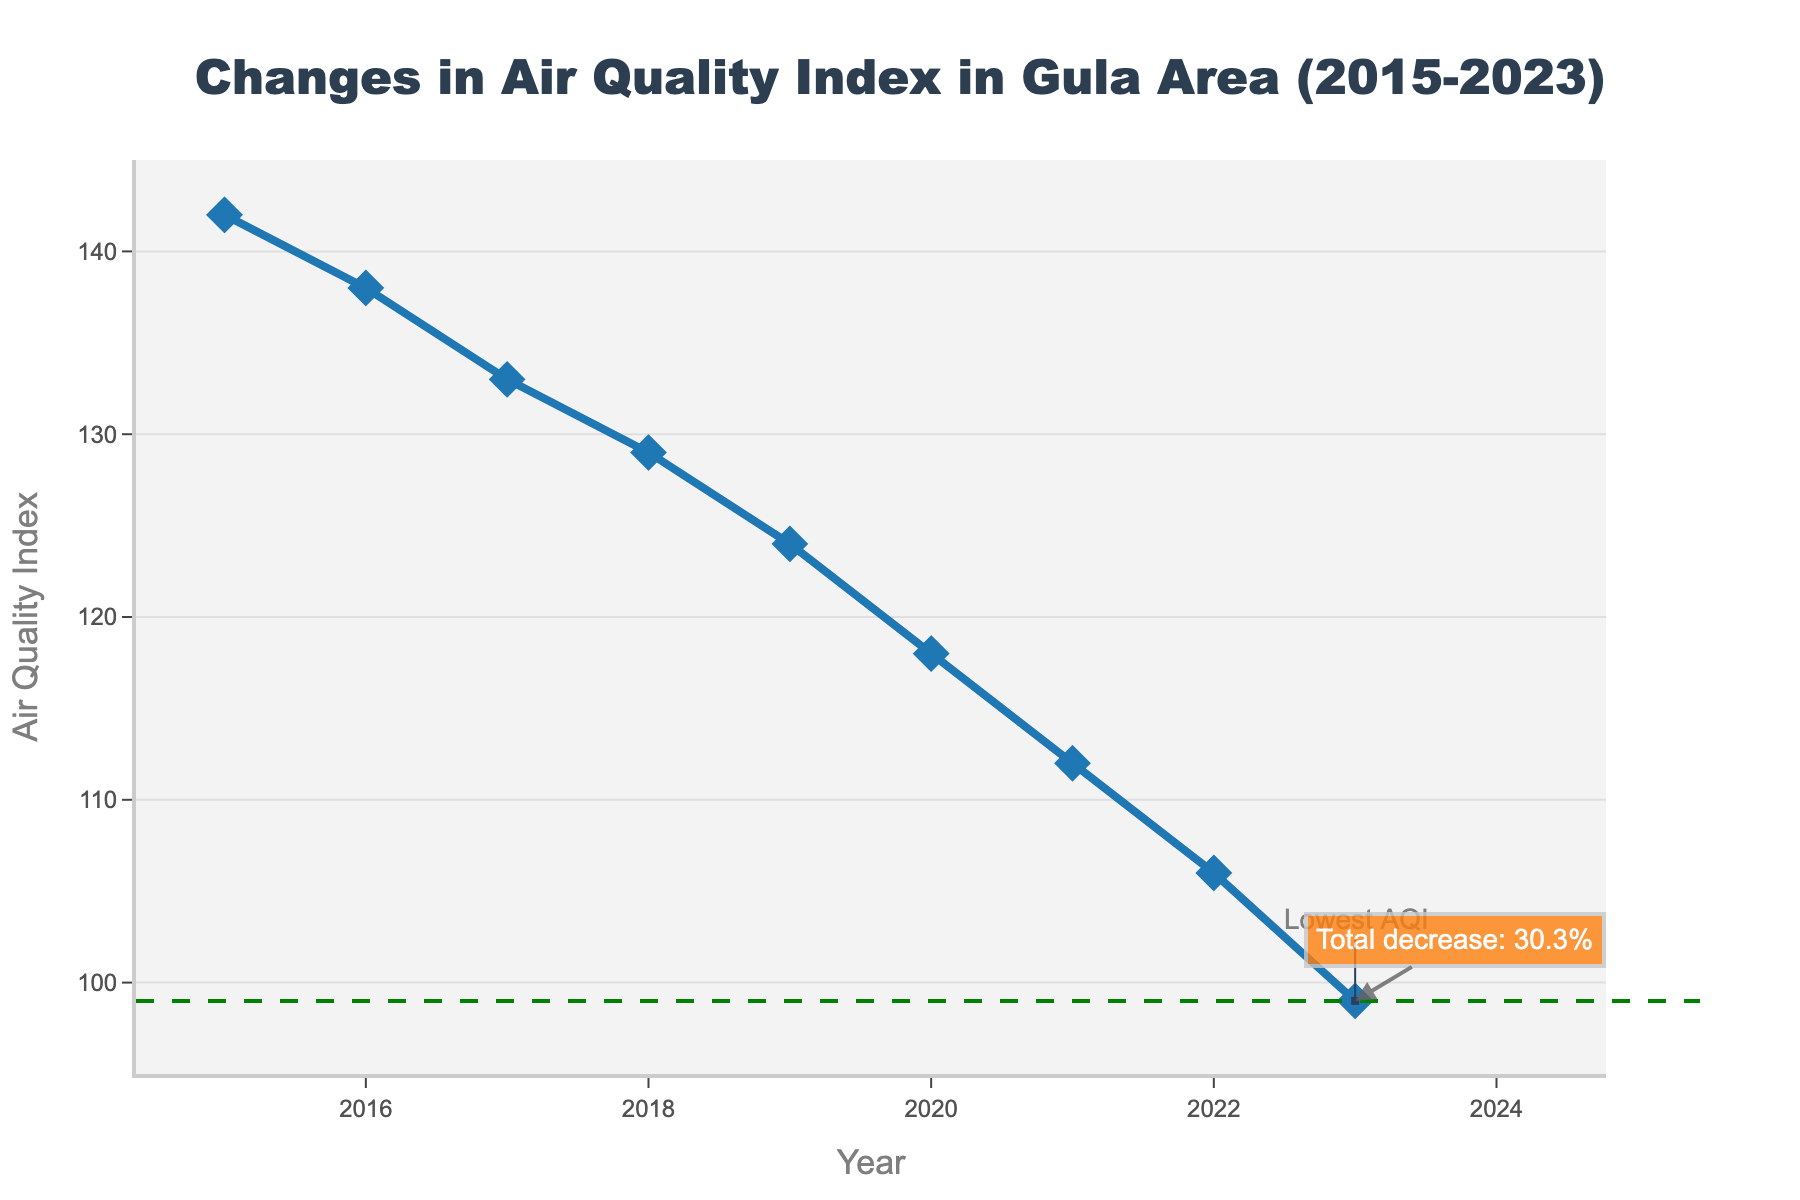What is the general trend of the Air Quality Index from 2015 to 2023? The general trend can be observed by looking at the line plot from left (2015) to right (2023). The line shows a steady decrease in the Air Quality Index over the years.
Answer: Decreasing By how much did the Air Quality Index decrease from 2015 to 2023? To find the decrease, subtract the Air Quality Index in 2023 (99) from the Air Quality Index in 2015 (142). So, 142 - 99 equals 43.
Answer: 43 What is the lowest Air Quality Index value in the plotted period, and in which year did it occur? The lowest value is marked by the dashed green line, and the annotation indicates that it is in 2023 with a value of 99.
Answer: 99 in 2023 By what percentage did the Air Quality Index decrease from 2015 to 2023? The percentage decrease is calculated as follows: ((142 - 99) / 142) * 100 = 30.3%. This is also annotated on the plot.
Answer: 30.3% In which year did the Air Quality Index see the largest single-year improvement, and what was that improvement? By comparing the yearly differences in the Air Quality Index on the plot, the largest change is between 2019 and 2020, where the index dropped from 124 to 118, giving a change of 6.
Answer: 2019 to 2020, 6 How does the Air Quality Index in 2020 compare with that in 2016? By looking at the plot, the Air Quality Index in 2020 (118) is lower than in 2016 (138).
Answer: 2020 is lower than 2016 What color and shape are used to represent the data points on the plot? The data points are marked using blue diamond-shaped markers on the plot.
Answer: Blue diamonds What is the average Air Quality Index from 2015 to 2023? The average is calculated by summing all the yearly values and dividing by the number of years: (142 + 138 + 133 + 129 + 124 + 118 + 112 + 106 + 99) / 9 = 122.3.
Answer: 122.3 